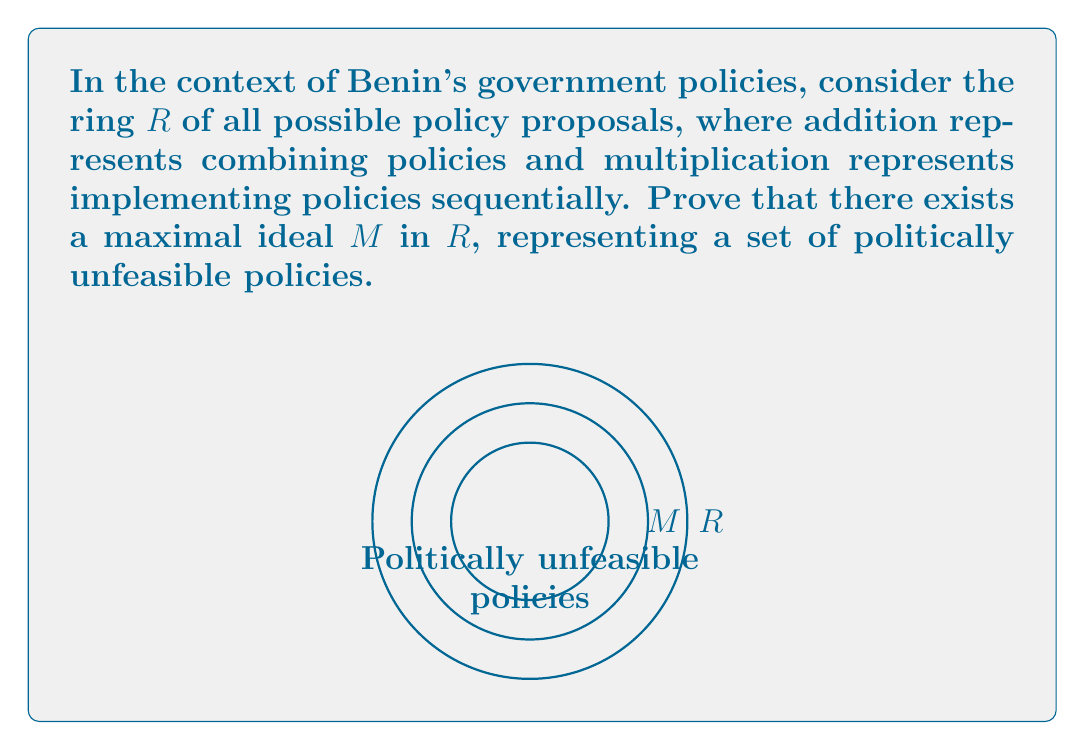Help me with this question. To prove the existence of a maximal ideal in the ring $R$ of government policies, we can use Zorn's Lemma. Let's proceed step by step:

1) First, we need to define a partial order on the set of proper ideals of $R$. Let $\mathcal{I}$ be the set of all proper ideals of $R$. We can define a partial order $\subseteq$ on $\mathcal{I}$ by set inclusion.

2) Now, we need to show that every chain in $(\mathcal{I}, \subseteq)$ has an upper bound in $\mathcal{I}$. Let $C$ be a chain in $\mathcal{I}$. Define $I = \bigcup_{J \in C} J$.

3) We need to prove that $I$ is an ideal of $R$:
   a) $0 \in I$ since $0$ is in every ideal $J \in C$.
   b) For $a, b \in I$, $\exists J_1, J_2 \in C$ such that $a \in J_1$ and $b \in J_2$. Since $C$ is a chain, either $J_1 \subseteq J_2$ or $J_2 \subseteq J_1$. So $a, b$ are in the larger of $J_1$ and $J_2$, and thus $a - b \in I$.
   c) For $a \in I$ and $r \in R$, $\exists J \in C$ such that $a \in J$. Since $J$ is an ideal, $ra \in J \subseteq I$.

4) $I$ is proper because if $1 \in I$, then $1 \in J$ for some $J \in C$, contradicting that $J$ is proper.

5) Therefore, $I$ is an upper bound for $C$ in $\mathcal{I}$.

6) By Zorn's Lemma, $\mathcal{I}$ has a maximal element $M$. This $M$ is a maximal ideal in $R$.

In the context of Benin's government policies, $M$ represents a maximal set of politically unfeasible policies. Any policy outside $M$, when combined with policies in $M$, would result in a set of policies that is no longer an ideal, meaning it becomes politically feasible.
Answer: A maximal ideal exists in $R$ by Zorn's Lemma. 